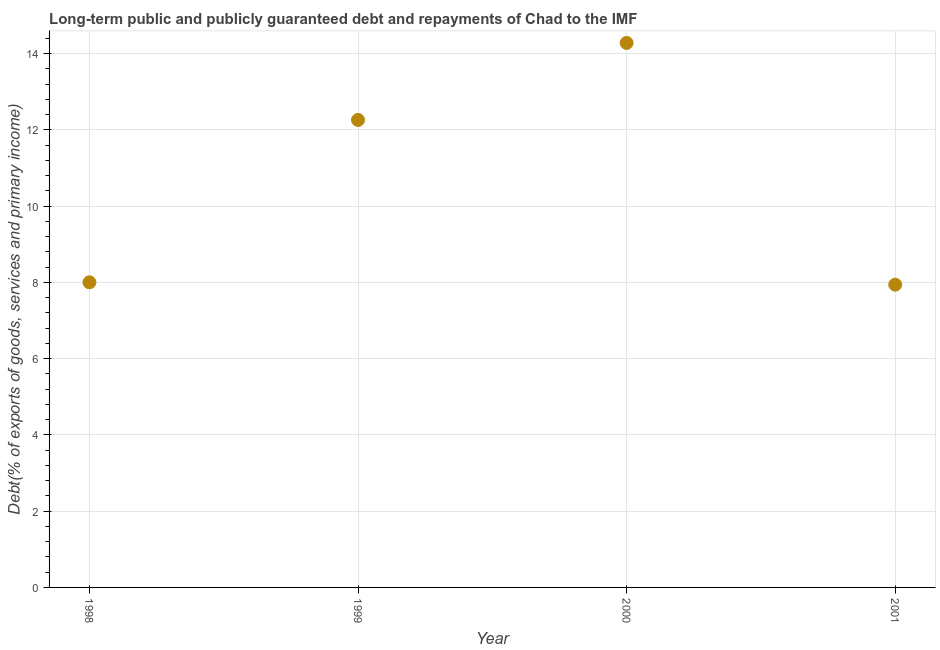What is the debt service in 2000?
Make the answer very short. 14.28. Across all years, what is the maximum debt service?
Your response must be concise. 14.28. Across all years, what is the minimum debt service?
Provide a succinct answer. 7.94. In which year was the debt service maximum?
Your answer should be compact. 2000. In which year was the debt service minimum?
Offer a very short reply. 2001. What is the sum of the debt service?
Keep it short and to the point. 42.47. What is the difference between the debt service in 2000 and 2001?
Keep it short and to the point. 6.34. What is the average debt service per year?
Offer a very short reply. 10.62. What is the median debt service?
Give a very brief answer. 10.13. What is the ratio of the debt service in 2000 to that in 2001?
Provide a short and direct response. 1.8. What is the difference between the highest and the second highest debt service?
Keep it short and to the point. 2.02. What is the difference between the highest and the lowest debt service?
Give a very brief answer. 6.34. Does the graph contain any zero values?
Your answer should be compact. No. Does the graph contain grids?
Offer a very short reply. Yes. What is the title of the graph?
Offer a terse response. Long-term public and publicly guaranteed debt and repayments of Chad to the IMF. What is the label or title of the X-axis?
Provide a succinct answer. Year. What is the label or title of the Y-axis?
Provide a short and direct response. Debt(% of exports of goods, services and primary income). What is the Debt(% of exports of goods, services and primary income) in 1998?
Offer a very short reply. 8. What is the Debt(% of exports of goods, services and primary income) in 1999?
Offer a very short reply. 12.26. What is the Debt(% of exports of goods, services and primary income) in 2000?
Provide a succinct answer. 14.28. What is the Debt(% of exports of goods, services and primary income) in 2001?
Keep it short and to the point. 7.94. What is the difference between the Debt(% of exports of goods, services and primary income) in 1998 and 1999?
Give a very brief answer. -4.26. What is the difference between the Debt(% of exports of goods, services and primary income) in 1998 and 2000?
Make the answer very short. -6.28. What is the difference between the Debt(% of exports of goods, services and primary income) in 1998 and 2001?
Provide a succinct answer. 0.06. What is the difference between the Debt(% of exports of goods, services and primary income) in 1999 and 2000?
Make the answer very short. -2.02. What is the difference between the Debt(% of exports of goods, services and primary income) in 1999 and 2001?
Provide a succinct answer. 4.32. What is the difference between the Debt(% of exports of goods, services and primary income) in 2000 and 2001?
Your answer should be compact. 6.34. What is the ratio of the Debt(% of exports of goods, services and primary income) in 1998 to that in 1999?
Give a very brief answer. 0.65. What is the ratio of the Debt(% of exports of goods, services and primary income) in 1998 to that in 2000?
Give a very brief answer. 0.56. What is the ratio of the Debt(% of exports of goods, services and primary income) in 1999 to that in 2000?
Your answer should be compact. 0.86. What is the ratio of the Debt(% of exports of goods, services and primary income) in 1999 to that in 2001?
Provide a succinct answer. 1.54. What is the ratio of the Debt(% of exports of goods, services and primary income) in 2000 to that in 2001?
Give a very brief answer. 1.8. 